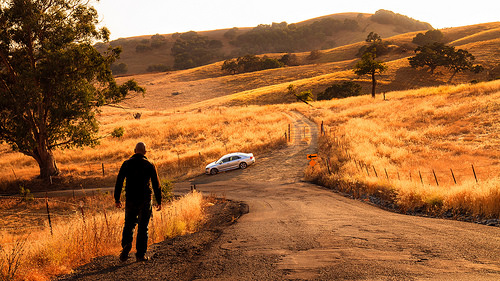<image>
Can you confirm if the car is behind the person? Yes. From this viewpoint, the car is positioned behind the person, with the person partially or fully occluding the car. Where is the hay in relation to the road? Is it on the road? Yes. Looking at the image, I can see the hay is positioned on top of the road, with the road providing support. 